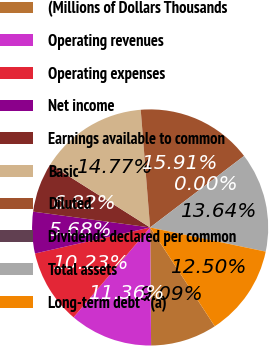Convert chart to OTSL. <chart><loc_0><loc_0><loc_500><loc_500><pie_chart><fcel>(Millions of Dollars Thousands<fcel>Operating revenues<fcel>Operating expenses<fcel>Net income<fcel>Earnings available to common<fcel>Basic<fcel>Diluted<fcel>Dividends declared per common<fcel>Total assets<fcel>Long-term debt ^(a)<nl><fcel>9.09%<fcel>11.36%<fcel>10.23%<fcel>5.68%<fcel>6.82%<fcel>14.77%<fcel>15.91%<fcel>0.0%<fcel>13.64%<fcel>12.5%<nl></chart> 